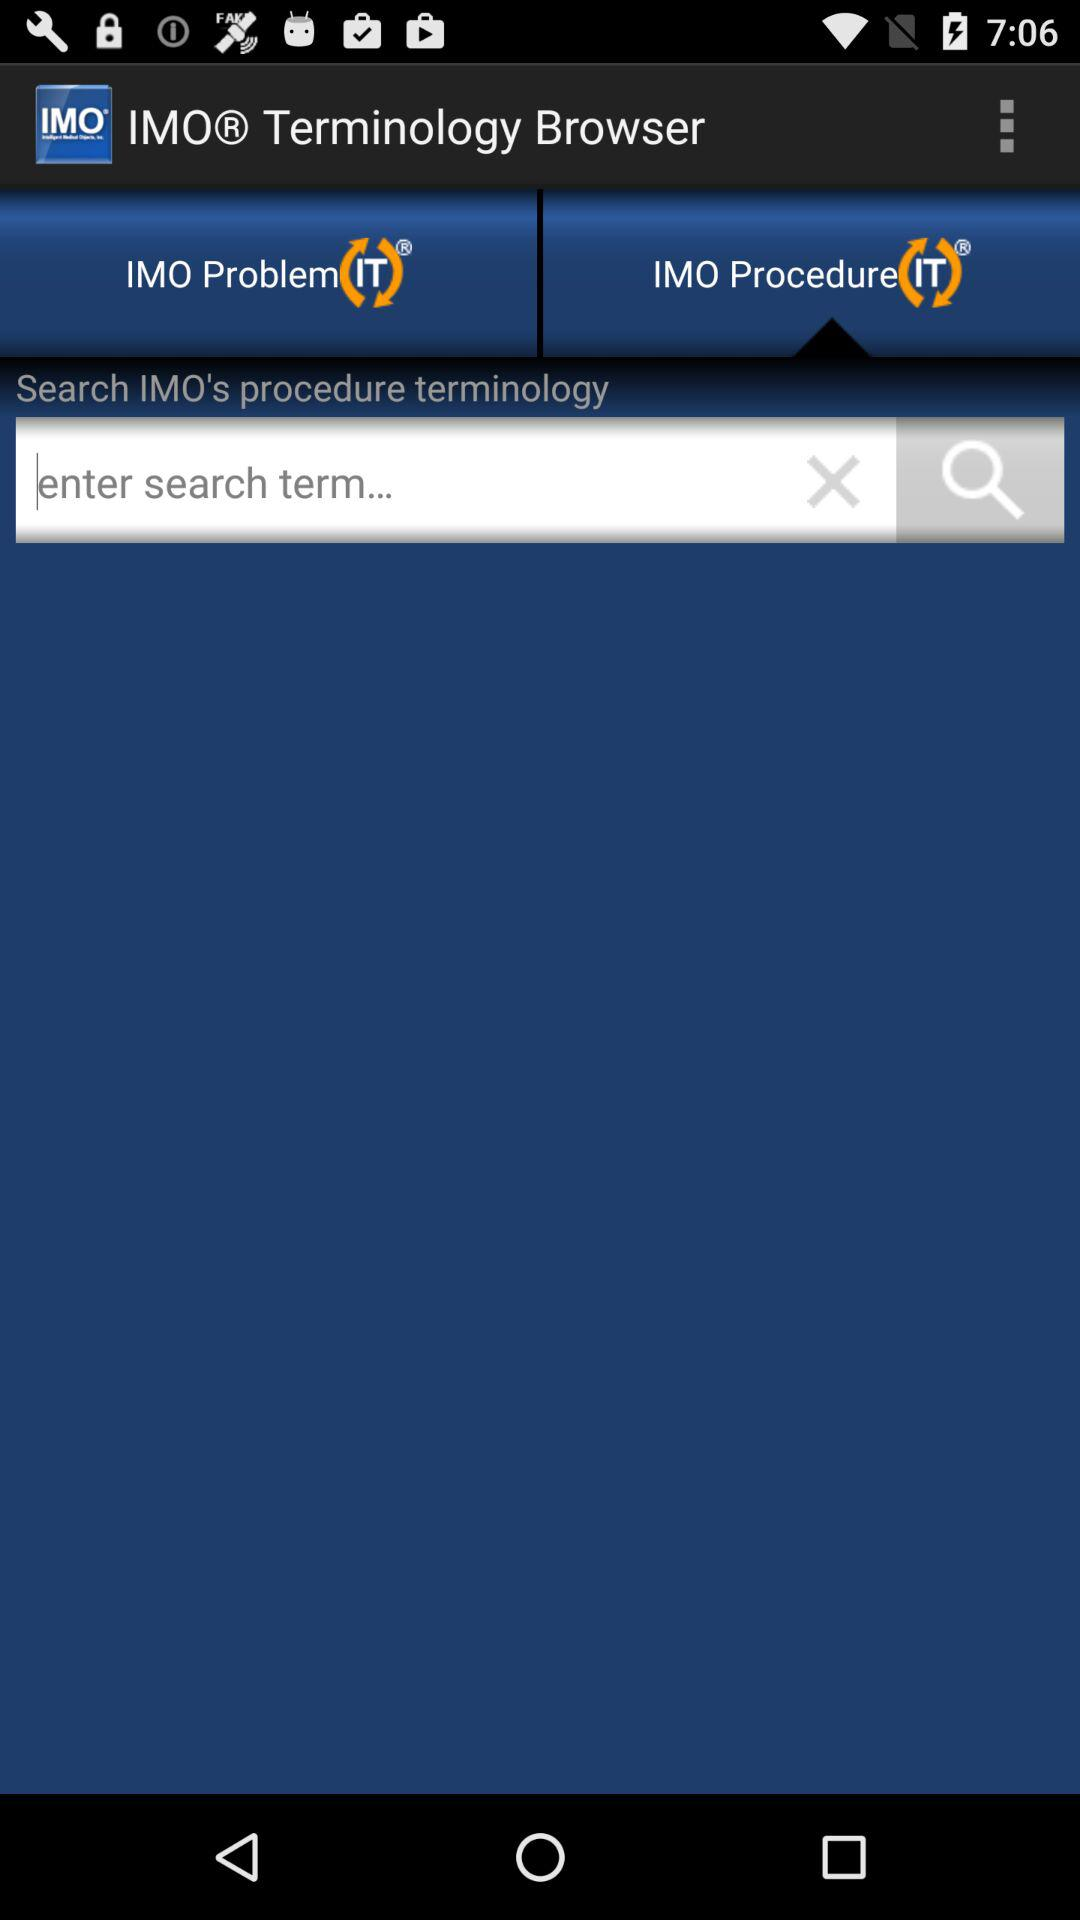What is entered into the search bar?
When the provided information is insufficient, respond with <no answer>. <no answer> 